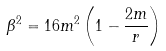<formula> <loc_0><loc_0><loc_500><loc_500>\beta ^ { 2 } = 1 6 m ^ { 2 } \left ( 1 - \frac { 2 m } { r } \right )</formula> 